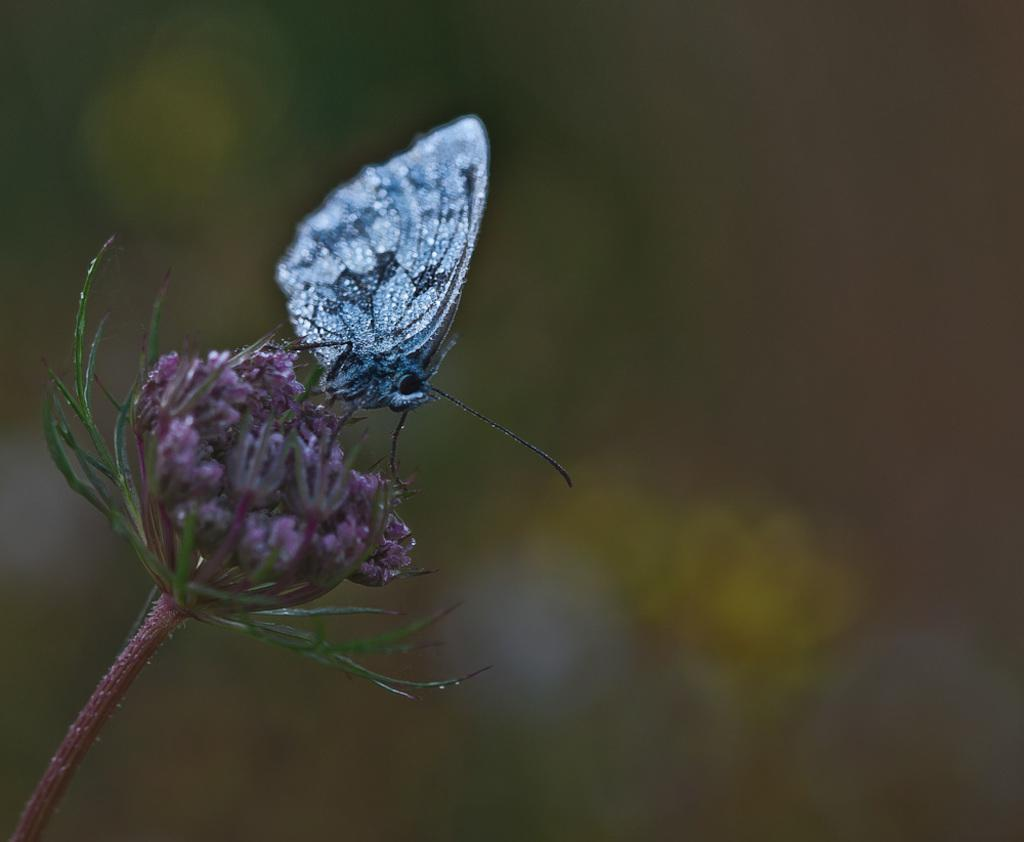What is the main subject in the center of the image? There is a flower in the center of the image. Is there anything else on the flower? Yes, there is a silver-colored butterfly on the flower. Can you hear the bell ringing in the image? There is no bell present in the image, so it cannot be heard. 